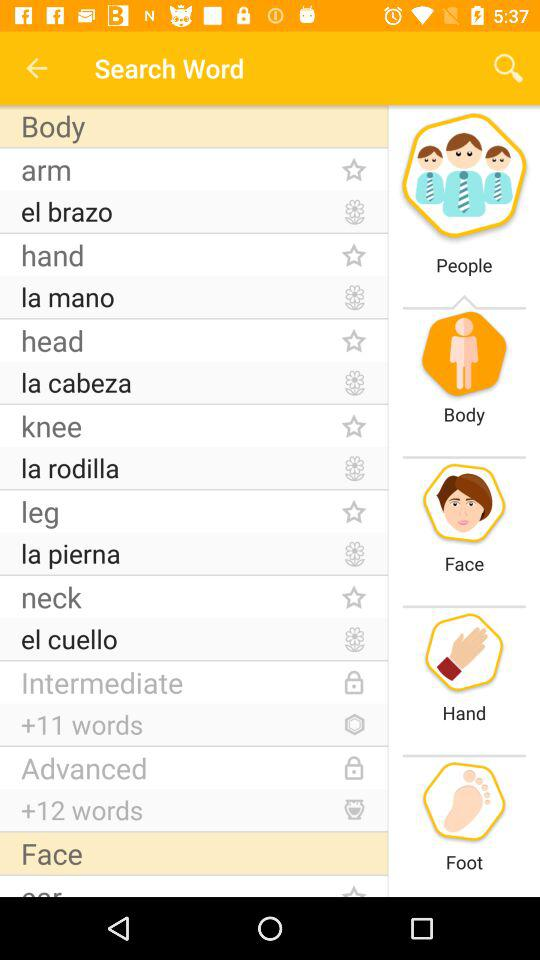What's the number of words in "Advanced"? There are 12 words in "Advanced". 